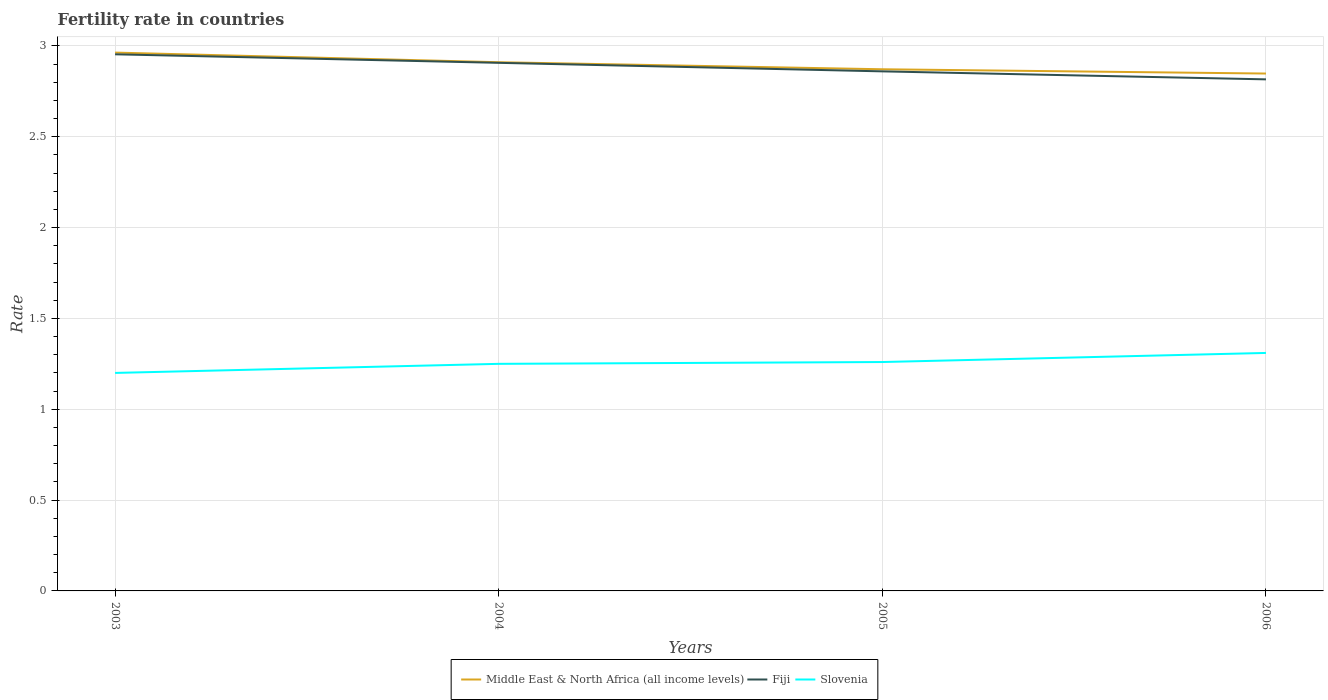How many different coloured lines are there?
Make the answer very short. 3. Across all years, what is the maximum fertility rate in Middle East & North Africa (all income levels)?
Make the answer very short. 2.85. What is the total fertility rate in Slovenia in the graph?
Your answer should be compact. -0.01. What is the difference between the highest and the second highest fertility rate in Slovenia?
Ensure brevity in your answer.  0.11. What is the difference between the highest and the lowest fertility rate in Slovenia?
Your answer should be very brief. 2. Is the fertility rate in Slovenia strictly greater than the fertility rate in Fiji over the years?
Give a very brief answer. Yes. How many lines are there?
Provide a short and direct response. 3. Are the values on the major ticks of Y-axis written in scientific E-notation?
Ensure brevity in your answer.  No. How many legend labels are there?
Your answer should be very brief. 3. How are the legend labels stacked?
Offer a terse response. Horizontal. What is the title of the graph?
Give a very brief answer. Fertility rate in countries. What is the label or title of the X-axis?
Your answer should be compact. Years. What is the label or title of the Y-axis?
Provide a short and direct response. Rate. What is the Rate in Middle East & North Africa (all income levels) in 2003?
Offer a terse response. 2.96. What is the Rate of Fiji in 2003?
Your answer should be compact. 2.95. What is the Rate in Middle East & North Africa (all income levels) in 2004?
Your answer should be very brief. 2.91. What is the Rate in Fiji in 2004?
Give a very brief answer. 2.91. What is the Rate of Slovenia in 2004?
Make the answer very short. 1.25. What is the Rate in Middle East & North Africa (all income levels) in 2005?
Your answer should be compact. 2.87. What is the Rate of Fiji in 2005?
Your response must be concise. 2.86. What is the Rate in Slovenia in 2005?
Provide a succinct answer. 1.26. What is the Rate in Middle East & North Africa (all income levels) in 2006?
Provide a short and direct response. 2.85. What is the Rate of Fiji in 2006?
Your answer should be very brief. 2.82. What is the Rate in Slovenia in 2006?
Make the answer very short. 1.31. Across all years, what is the maximum Rate in Middle East & North Africa (all income levels)?
Provide a succinct answer. 2.96. Across all years, what is the maximum Rate in Fiji?
Provide a short and direct response. 2.95. Across all years, what is the maximum Rate of Slovenia?
Offer a terse response. 1.31. Across all years, what is the minimum Rate in Middle East & North Africa (all income levels)?
Offer a very short reply. 2.85. Across all years, what is the minimum Rate in Fiji?
Offer a terse response. 2.82. Across all years, what is the minimum Rate of Slovenia?
Your response must be concise. 1.2. What is the total Rate of Middle East & North Africa (all income levels) in the graph?
Your response must be concise. 11.59. What is the total Rate of Fiji in the graph?
Provide a short and direct response. 11.54. What is the total Rate in Slovenia in the graph?
Offer a very short reply. 5.02. What is the difference between the Rate of Middle East & North Africa (all income levels) in 2003 and that in 2004?
Ensure brevity in your answer.  0.05. What is the difference between the Rate of Fiji in 2003 and that in 2004?
Ensure brevity in your answer.  0.05. What is the difference between the Rate in Slovenia in 2003 and that in 2004?
Give a very brief answer. -0.05. What is the difference between the Rate in Middle East & North Africa (all income levels) in 2003 and that in 2005?
Give a very brief answer. 0.09. What is the difference between the Rate in Fiji in 2003 and that in 2005?
Ensure brevity in your answer.  0.09. What is the difference between the Rate in Slovenia in 2003 and that in 2005?
Your answer should be compact. -0.06. What is the difference between the Rate of Middle East & North Africa (all income levels) in 2003 and that in 2006?
Ensure brevity in your answer.  0.12. What is the difference between the Rate in Fiji in 2003 and that in 2006?
Keep it short and to the point. 0.14. What is the difference between the Rate in Slovenia in 2003 and that in 2006?
Offer a very short reply. -0.11. What is the difference between the Rate of Middle East & North Africa (all income levels) in 2004 and that in 2005?
Keep it short and to the point. 0.04. What is the difference between the Rate of Fiji in 2004 and that in 2005?
Offer a terse response. 0.05. What is the difference between the Rate in Slovenia in 2004 and that in 2005?
Make the answer very short. -0.01. What is the difference between the Rate of Middle East & North Africa (all income levels) in 2004 and that in 2006?
Offer a very short reply. 0.06. What is the difference between the Rate of Fiji in 2004 and that in 2006?
Offer a terse response. 0.09. What is the difference between the Rate of Slovenia in 2004 and that in 2006?
Provide a short and direct response. -0.06. What is the difference between the Rate in Middle East & North Africa (all income levels) in 2005 and that in 2006?
Offer a very short reply. 0.02. What is the difference between the Rate of Fiji in 2005 and that in 2006?
Your answer should be compact. 0.04. What is the difference between the Rate in Middle East & North Africa (all income levels) in 2003 and the Rate in Fiji in 2004?
Your answer should be very brief. 0.06. What is the difference between the Rate in Middle East & North Africa (all income levels) in 2003 and the Rate in Slovenia in 2004?
Offer a very short reply. 1.71. What is the difference between the Rate of Fiji in 2003 and the Rate of Slovenia in 2004?
Offer a very short reply. 1.7. What is the difference between the Rate of Middle East & North Africa (all income levels) in 2003 and the Rate of Fiji in 2005?
Provide a succinct answer. 0.1. What is the difference between the Rate in Middle East & North Africa (all income levels) in 2003 and the Rate in Slovenia in 2005?
Provide a short and direct response. 1.7. What is the difference between the Rate of Fiji in 2003 and the Rate of Slovenia in 2005?
Offer a terse response. 1.69. What is the difference between the Rate of Middle East & North Africa (all income levels) in 2003 and the Rate of Fiji in 2006?
Your response must be concise. 0.15. What is the difference between the Rate in Middle East & North Africa (all income levels) in 2003 and the Rate in Slovenia in 2006?
Provide a short and direct response. 1.65. What is the difference between the Rate of Fiji in 2003 and the Rate of Slovenia in 2006?
Your response must be concise. 1.64. What is the difference between the Rate in Middle East & North Africa (all income levels) in 2004 and the Rate in Fiji in 2005?
Your answer should be compact. 0.05. What is the difference between the Rate of Middle East & North Africa (all income levels) in 2004 and the Rate of Slovenia in 2005?
Provide a succinct answer. 1.65. What is the difference between the Rate in Fiji in 2004 and the Rate in Slovenia in 2005?
Keep it short and to the point. 1.65. What is the difference between the Rate of Middle East & North Africa (all income levels) in 2004 and the Rate of Fiji in 2006?
Keep it short and to the point. 0.09. What is the difference between the Rate in Middle East & North Africa (all income levels) in 2004 and the Rate in Slovenia in 2006?
Give a very brief answer. 1.6. What is the difference between the Rate in Fiji in 2004 and the Rate in Slovenia in 2006?
Make the answer very short. 1.6. What is the difference between the Rate of Middle East & North Africa (all income levels) in 2005 and the Rate of Fiji in 2006?
Provide a succinct answer. 0.06. What is the difference between the Rate in Middle East & North Africa (all income levels) in 2005 and the Rate in Slovenia in 2006?
Offer a very short reply. 1.56. What is the difference between the Rate in Fiji in 2005 and the Rate in Slovenia in 2006?
Offer a terse response. 1.55. What is the average Rate of Middle East & North Africa (all income levels) per year?
Your answer should be compact. 2.9. What is the average Rate of Fiji per year?
Make the answer very short. 2.88. What is the average Rate in Slovenia per year?
Your answer should be compact. 1.25. In the year 2003, what is the difference between the Rate in Middle East & North Africa (all income levels) and Rate in Fiji?
Your answer should be compact. 0.01. In the year 2003, what is the difference between the Rate of Middle East & North Africa (all income levels) and Rate of Slovenia?
Keep it short and to the point. 1.76. In the year 2003, what is the difference between the Rate in Fiji and Rate in Slovenia?
Offer a terse response. 1.75. In the year 2004, what is the difference between the Rate of Middle East & North Africa (all income levels) and Rate of Fiji?
Your answer should be very brief. 0. In the year 2004, what is the difference between the Rate in Middle East & North Africa (all income levels) and Rate in Slovenia?
Offer a terse response. 1.66. In the year 2004, what is the difference between the Rate in Fiji and Rate in Slovenia?
Make the answer very short. 1.66. In the year 2005, what is the difference between the Rate in Middle East & North Africa (all income levels) and Rate in Fiji?
Your answer should be compact. 0.01. In the year 2005, what is the difference between the Rate in Middle East & North Africa (all income levels) and Rate in Slovenia?
Make the answer very short. 1.61. In the year 2005, what is the difference between the Rate in Fiji and Rate in Slovenia?
Provide a short and direct response. 1.6. In the year 2006, what is the difference between the Rate of Middle East & North Africa (all income levels) and Rate of Fiji?
Keep it short and to the point. 0.03. In the year 2006, what is the difference between the Rate in Middle East & North Africa (all income levels) and Rate in Slovenia?
Offer a very short reply. 1.54. In the year 2006, what is the difference between the Rate of Fiji and Rate of Slovenia?
Offer a terse response. 1.51. What is the ratio of the Rate in Middle East & North Africa (all income levels) in 2003 to that in 2004?
Provide a short and direct response. 1.02. What is the ratio of the Rate of Fiji in 2003 to that in 2004?
Make the answer very short. 1.02. What is the ratio of the Rate of Slovenia in 2003 to that in 2004?
Offer a terse response. 0.96. What is the ratio of the Rate in Middle East & North Africa (all income levels) in 2003 to that in 2005?
Your response must be concise. 1.03. What is the ratio of the Rate of Fiji in 2003 to that in 2005?
Keep it short and to the point. 1.03. What is the ratio of the Rate of Slovenia in 2003 to that in 2005?
Give a very brief answer. 0.95. What is the ratio of the Rate in Middle East & North Africa (all income levels) in 2003 to that in 2006?
Offer a terse response. 1.04. What is the ratio of the Rate of Fiji in 2003 to that in 2006?
Keep it short and to the point. 1.05. What is the ratio of the Rate of Slovenia in 2003 to that in 2006?
Offer a terse response. 0.92. What is the ratio of the Rate in Middle East & North Africa (all income levels) in 2004 to that in 2005?
Your answer should be very brief. 1.01. What is the ratio of the Rate in Fiji in 2004 to that in 2005?
Make the answer very short. 1.02. What is the ratio of the Rate of Middle East & North Africa (all income levels) in 2004 to that in 2006?
Your answer should be very brief. 1.02. What is the ratio of the Rate in Fiji in 2004 to that in 2006?
Ensure brevity in your answer.  1.03. What is the ratio of the Rate in Slovenia in 2004 to that in 2006?
Your answer should be very brief. 0.95. What is the ratio of the Rate of Middle East & North Africa (all income levels) in 2005 to that in 2006?
Ensure brevity in your answer.  1.01. What is the ratio of the Rate in Fiji in 2005 to that in 2006?
Give a very brief answer. 1.02. What is the ratio of the Rate in Slovenia in 2005 to that in 2006?
Offer a terse response. 0.96. What is the difference between the highest and the second highest Rate of Middle East & North Africa (all income levels)?
Give a very brief answer. 0.05. What is the difference between the highest and the second highest Rate of Fiji?
Offer a very short reply. 0.05. What is the difference between the highest and the lowest Rate of Middle East & North Africa (all income levels)?
Your answer should be very brief. 0.12. What is the difference between the highest and the lowest Rate of Fiji?
Provide a short and direct response. 0.14. What is the difference between the highest and the lowest Rate in Slovenia?
Give a very brief answer. 0.11. 